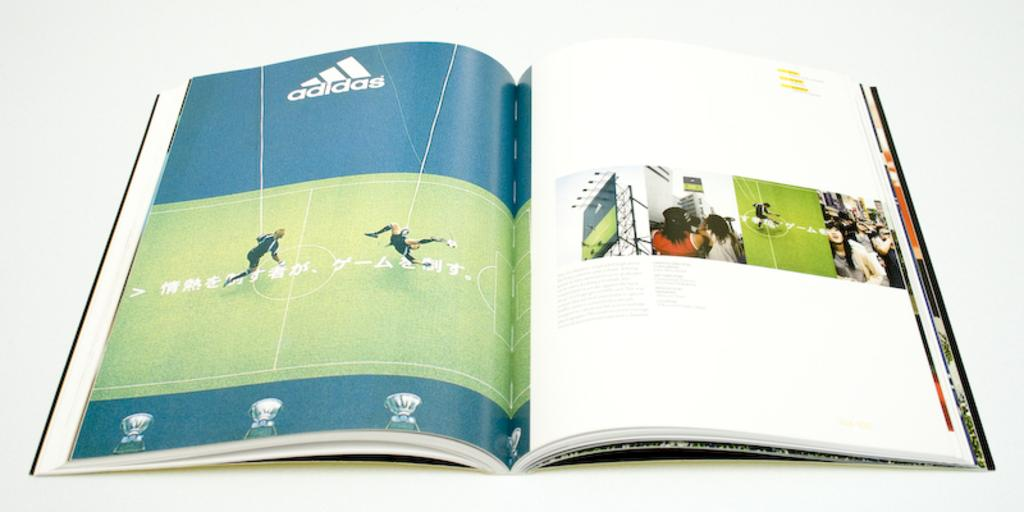<image>
Give a short and clear explanation of the subsequent image. a book opened to an advertisement for Adidas 